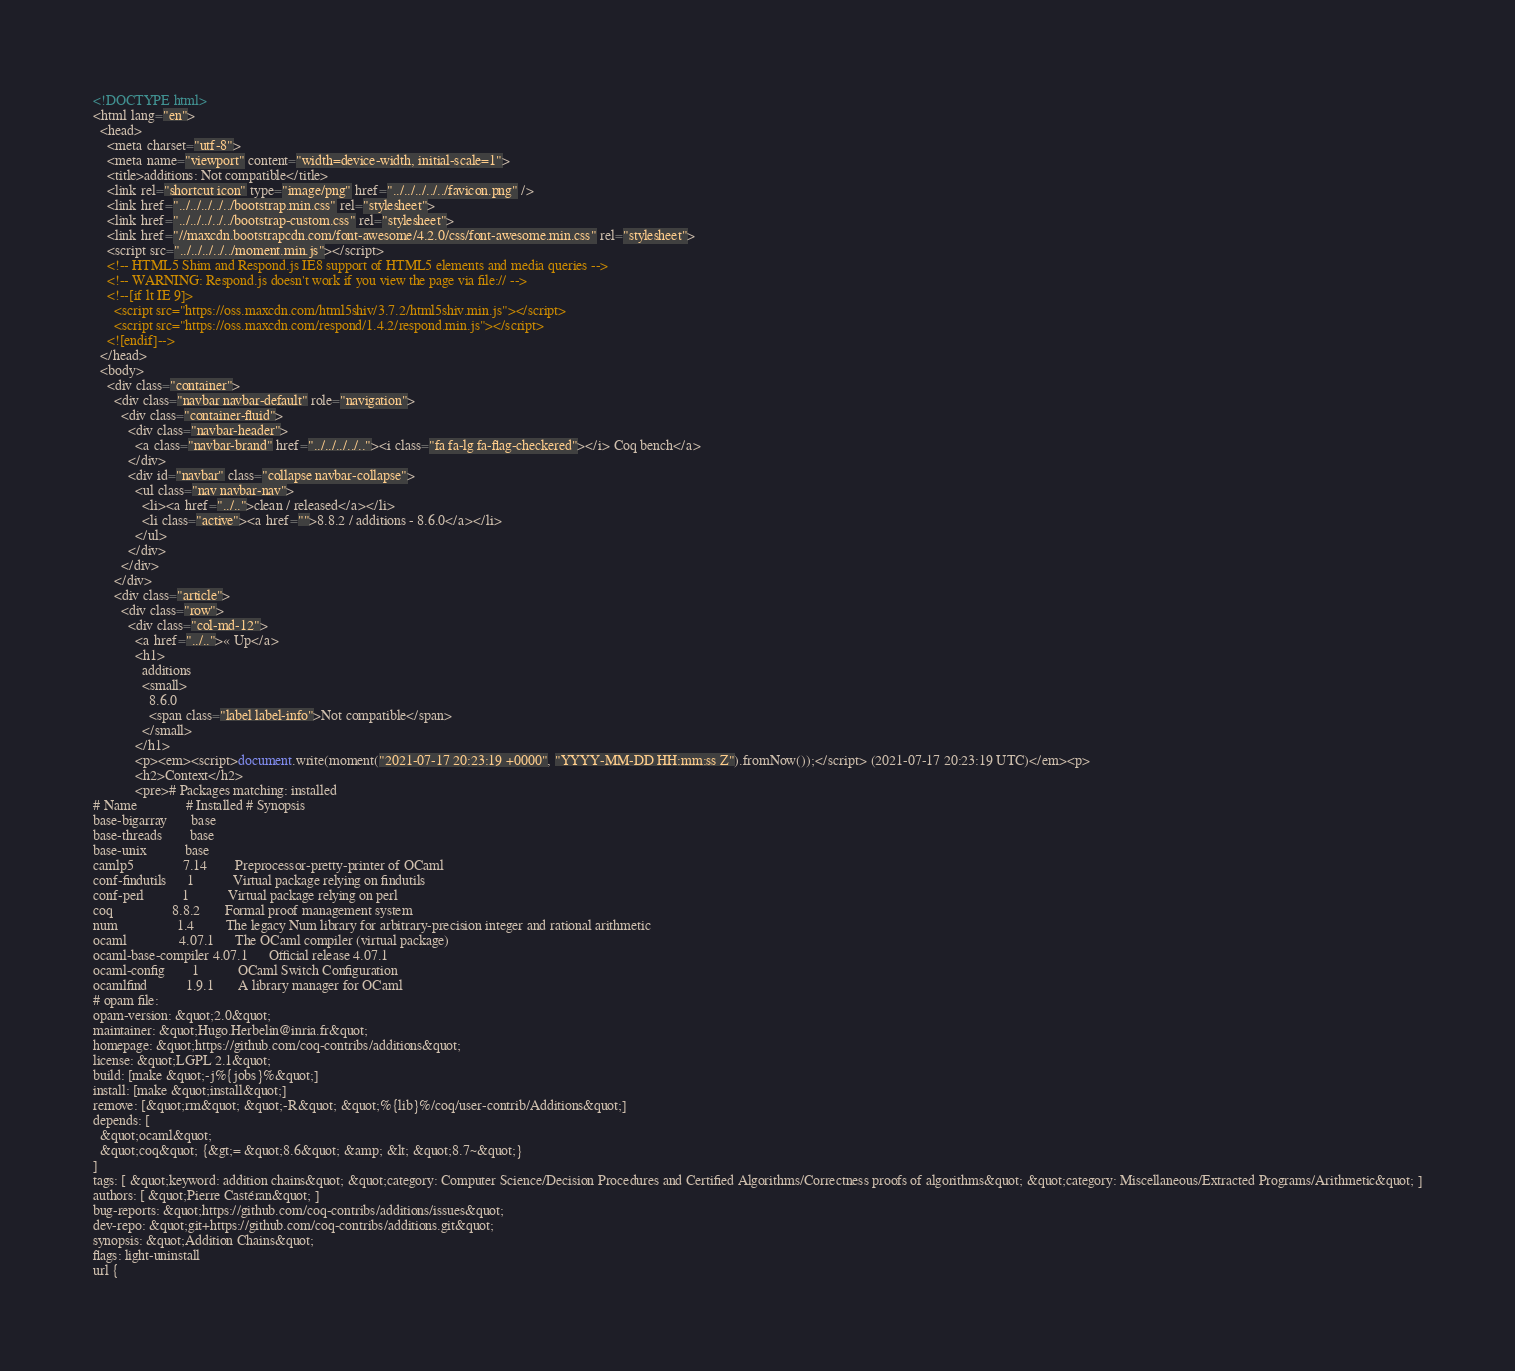<code> <loc_0><loc_0><loc_500><loc_500><_HTML_><!DOCTYPE html>
<html lang="en">
  <head>
    <meta charset="utf-8">
    <meta name="viewport" content="width=device-width, initial-scale=1">
    <title>additions: Not compatible</title>
    <link rel="shortcut icon" type="image/png" href="../../../../../favicon.png" />
    <link href="../../../../../bootstrap.min.css" rel="stylesheet">
    <link href="../../../../../bootstrap-custom.css" rel="stylesheet">
    <link href="//maxcdn.bootstrapcdn.com/font-awesome/4.2.0/css/font-awesome.min.css" rel="stylesheet">
    <script src="../../../../../moment.min.js"></script>
    <!-- HTML5 Shim and Respond.js IE8 support of HTML5 elements and media queries -->
    <!-- WARNING: Respond.js doesn't work if you view the page via file:// -->
    <!--[if lt IE 9]>
      <script src="https://oss.maxcdn.com/html5shiv/3.7.2/html5shiv.min.js"></script>
      <script src="https://oss.maxcdn.com/respond/1.4.2/respond.min.js"></script>
    <![endif]-->
  </head>
  <body>
    <div class="container">
      <div class="navbar navbar-default" role="navigation">
        <div class="container-fluid">
          <div class="navbar-header">
            <a class="navbar-brand" href="../../../../.."><i class="fa fa-lg fa-flag-checkered"></i> Coq bench</a>
          </div>
          <div id="navbar" class="collapse navbar-collapse">
            <ul class="nav navbar-nav">
              <li><a href="../..">clean / released</a></li>
              <li class="active"><a href="">8.8.2 / additions - 8.6.0</a></li>
            </ul>
          </div>
        </div>
      </div>
      <div class="article">
        <div class="row">
          <div class="col-md-12">
            <a href="../..">« Up</a>
            <h1>
              additions
              <small>
                8.6.0
                <span class="label label-info">Not compatible</span>
              </small>
            </h1>
            <p><em><script>document.write(moment("2021-07-17 20:23:19 +0000", "YYYY-MM-DD HH:mm:ss Z").fromNow());</script> (2021-07-17 20:23:19 UTC)</em><p>
            <h2>Context</h2>
            <pre># Packages matching: installed
# Name              # Installed # Synopsis
base-bigarray       base
base-threads        base
base-unix           base
camlp5              7.14        Preprocessor-pretty-printer of OCaml
conf-findutils      1           Virtual package relying on findutils
conf-perl           1           Virtual package relying on perl
coq                 8.8.2       Formal proof management system
num                 1.4         The legacy Num library for arbitrary-precision integer and rational arithmetic
ocaml               4.07.1      The OCaml compiler (virtual package)
ocaml-base-compiler 4.07.1      Official release 4.07.1
ocaml-config        1           OCaml Switch Configuration
ocamlfind           1.9.1       A library manager for OCaml
# opam file:
opam-version: &quot;2.0&quot;
maintainer: &quot;Hugo.Herbelin@inria.fr&quot;
homepage: &quot;https://github.com/coq-contribs/additions&quot;
license: &quot;LGPL 2.1&quot;
build: [make &quot;-j%{jobs}%&quot;]
install: [make &quot;install&quot;]
remove: [&quot;rm&quot; &quot;-R&quot; &quot;%{lib}%/coq/user-contrib/Additions&quot;]
depends: [
  &quot;ocaml&quot;
  &quot;coq&quot; {&gt;= &quot;8.6&quot; &amp; &lt; &quot;8.7~&quot;}
]
tags: [ &quot;keyword: addition chains&quot; &quot;category: Computer Science/Decision Procedures and Certified Algorithms/Correctness proofs of algorithms&quot; &quot;category: Miscellaneous/Extracted Programs/Arithmetic&quot; ]
authors: [ &quot;Pierre Castéran&quot; ]
bug-reports: &quot;https://github.com/coq-contribs/additions/issues&quot;
dev-repo: &quot;git+https://github.com/coq-contribs/additions.git&quot;
synopsis: &quot;Addition Chains&quot;
flags: light-uninstall
url {</code> 